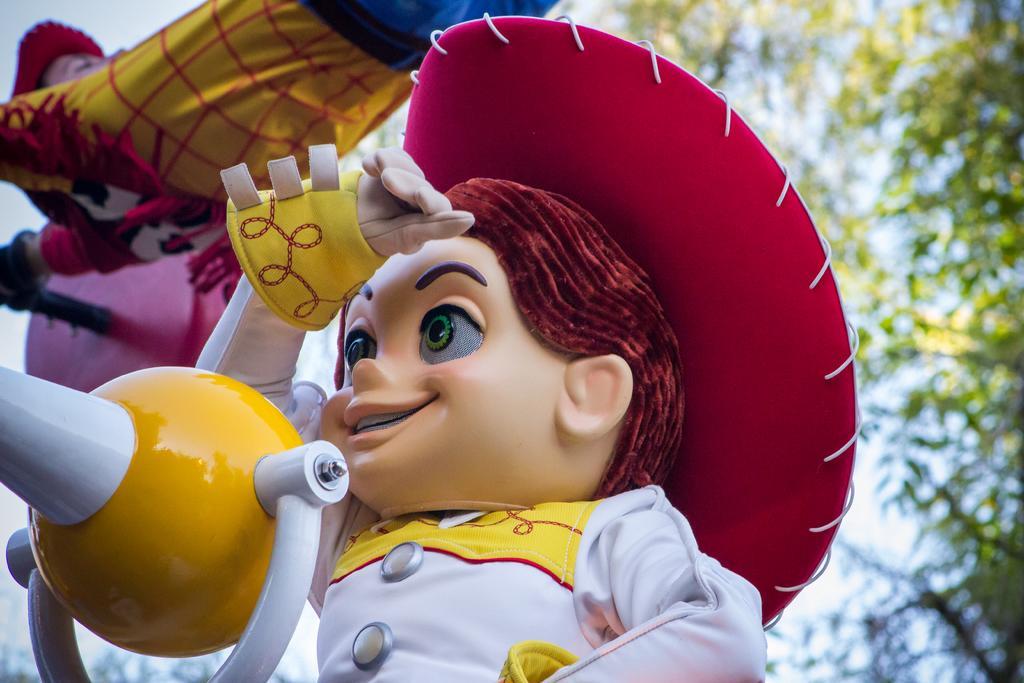Please provide a concise description of this image. In this image we can see few toys. There are few trees at the right side of the image. 